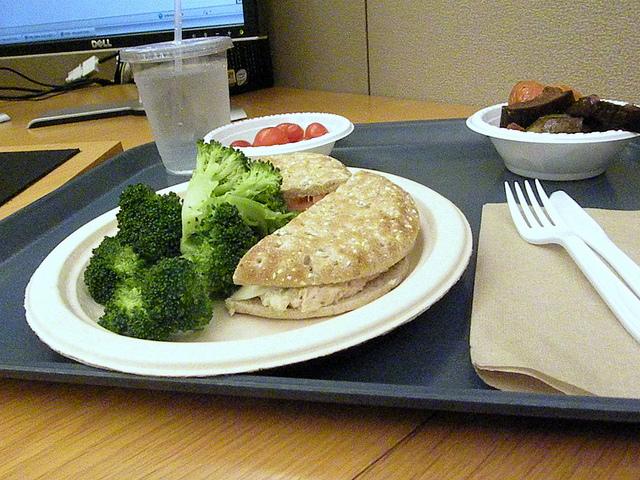What vegetable is in the bowl?
Short answer required. Broccoli. Is this meal healthy?
Concise answer only. Yes. What is the fork made of?
Give a very brief answer. Plastic. 